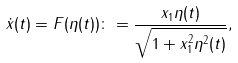<formula> <loc_0><loc_0><loc_500><loc_500>\dot { x } ( t ) = F ( \eta ( t ) ) \colon = \frac { x _ { 1 } \eta ( t ) } { \sqrt { 1 + x _ { 1 } ^ { 2 } \eta ^ { 2 } ( t ) } } ,</formula> 